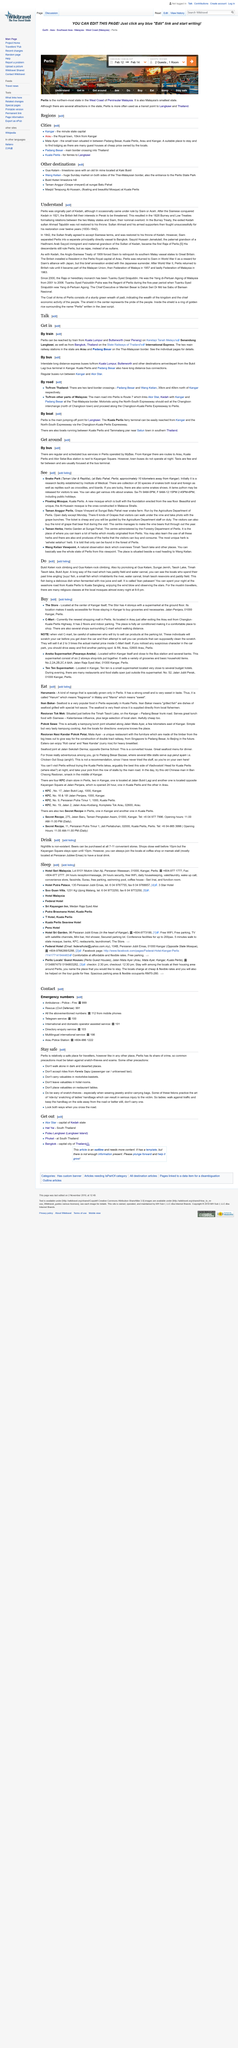Indicate a few pertinent items in this graphic. Ikan Bakar" is the Indonesian term for "grilled fish," which translates to English as a delicious and succulent dish of tender, flaky fish grilled to perfection over an open flame. This mouth-watering dish is a staple of Indonesian cuisine and is sure to delight any food lover. The Siamese conquest of Kedah occurred in 1821. C-mart is the newest shopping mall in the state of Perlis, offering a wide variety of products and services to meet the needs of its customers. Harumanis mango and ikan bakar are two types of food that are native to Perlis, a state in Malaysia. It is not the case that town buses operate at night in Kangar. In fact, they do not operate at night in Kangar. 